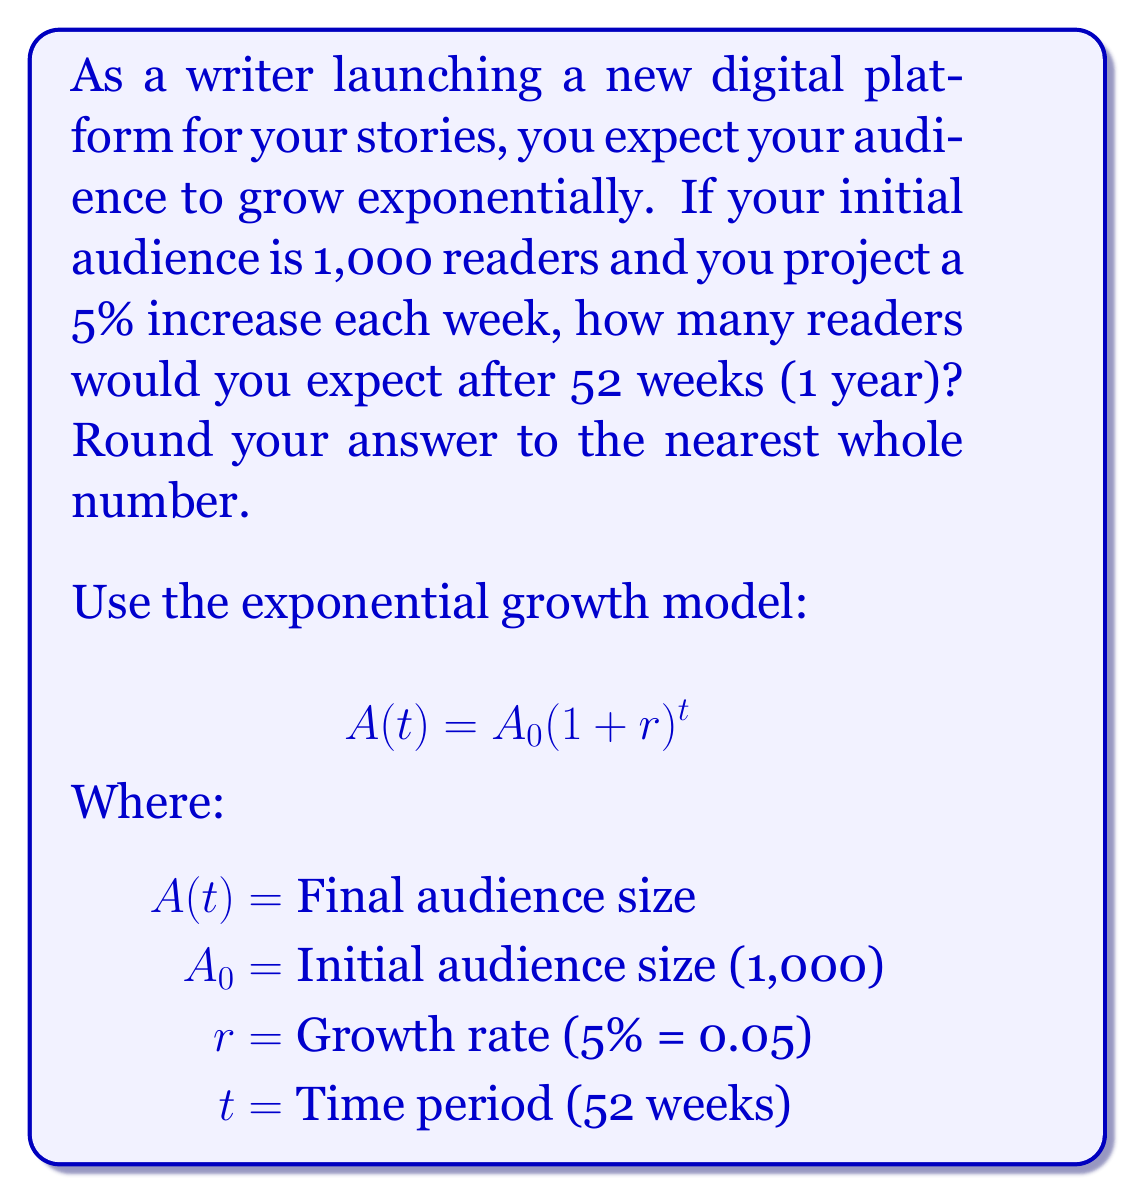Can you solve this math problem? Let's solve this step-by-step using the exponential growth model:

1) We have the following parameters:
   $A_0 = 1,000$ (initial audience)
   $r = 0.05$ (5% growth rate)
   $t = 52$ (weeks)

2) Plug these into the formula:
   $$A(52) = 1,000(1 + 0.05)^{52}$$

3) Simplify inside the parentheses:
   $$A(52) = 1,000(1.05)^{52}$$

4) Use a calculator to compute $(1.05)^{52}$:
   $(1.05)^{52} \approx 11.4674$

5) Multiply by the initial audience:
   $$A(52) = 1,000 \times 11.4674 = 11,467.4$$

6) Round to the nearest whole number:
   $$A(52) \approx 11,467$$

Therefore, after 52 weeks, you would expect approximately 11,467 readers.
Answer: 11,467 readers 